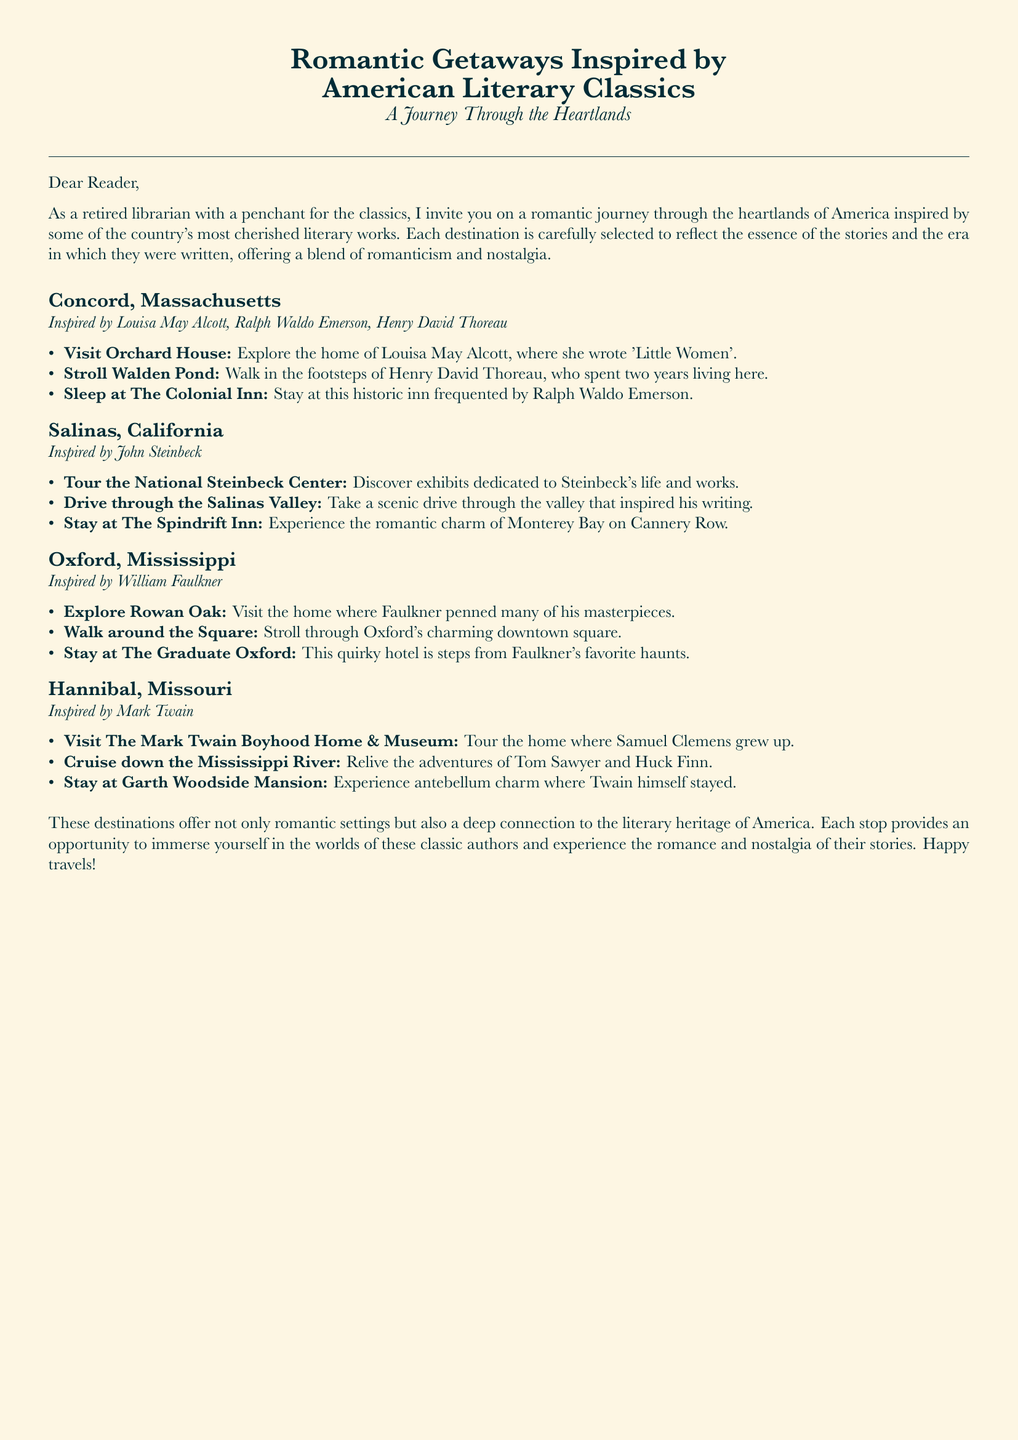What is the first destination listed? The first destination mentioned in the itinerary is Concord, Massachusetts.
Answer: Concord, Massachusetts Who is the author associated with Salinas, California? The author associated with Salinas, California is John Steinbeck.
Answer: John Steinbeck What activity can you do at Walden Pond? At Walden Pond, you can walk in the footsteps of Henry David Thoreau.
Answer: Walk in the footsteps of Henry David Thoreau How many activities are listed for Oxford, Mississippi? There are three activities listed for Oxford, Mississippi.
Answer: Three What is the name of the hotel in Hannibal, Missouri? The name of the hotel in Hannibal is Garth Woodside Mansion.
Answer: Garth Woodside Mansion Which author’s home can you visit in Oxford, Mississippi? You can visit the home of William Faulkner in Oxford, Mississippi.
Answer: William Faulkner What type of experience does The Spindrift Inn offer? The Spindrift Inn offers a romantic charm experience on Cannery Row.
Answer: Romantic charm What body of water is mentioned in connection with Mark Twain? The body of water mentioned is the Mississippi River.
Answer: Mississippi River Which town is associated with Louisa May Alcott and Ralph Waldo Emerson? The town associated with Louisa May Alcott and Ralph Waldo Emerson is Concord.
Answer: Concord 